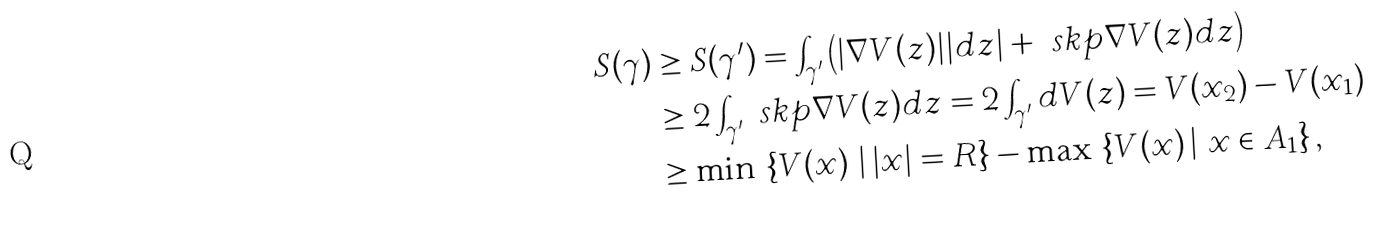Convert formula to latex. <formula><loc_0><loc_0><loc_500><loc_500>S ( \gamma ) & \geq S ( \gamma ^ { \prime } ) = \int _ { \gamma ^ { \prime } } \left ( | \nabla V ( z ) | | d z | + \ s k p { \nabla V ( z ) } { d z } \right ) \\ & \geq 2 \int _ { \gamma ^ { \prime } } \ s k p { \nabla V ( z ) } { d z } = 2 \int _ { \gamma ^ { \prime } } d V ( z ) = V ( x _ { 2 } ) - V ( x _ { 1 } ) \\ & \geq \min \, \left \{ V ( x ) \, \left | \, | x | = R \right \} - \max \, \left \{ V ( x ) \, \right | \, x \in A _ { 1 } \right \} ,</formula> 